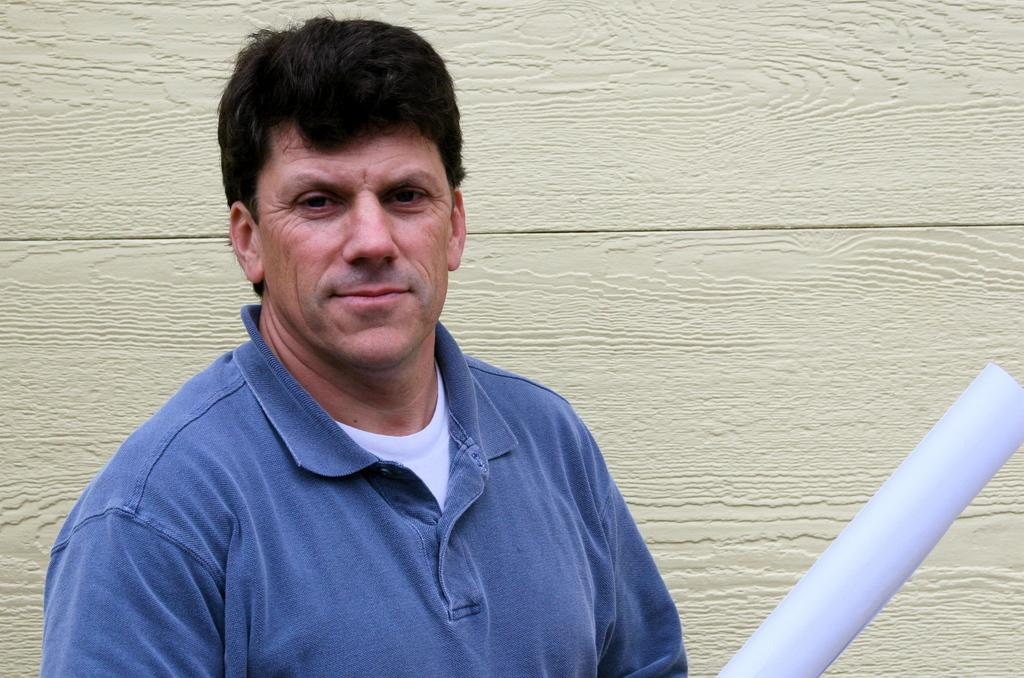What is the main subject of the image? There is an object in the image. Can you describe the person in the image? There is a man in the image, and he is smiling. What can be seen in the background of the image? There is a wall in the background of the image. What type of sweater is the man wearing in the image? There is no sweater mentioned in the image, and the man's clothing is not described. 